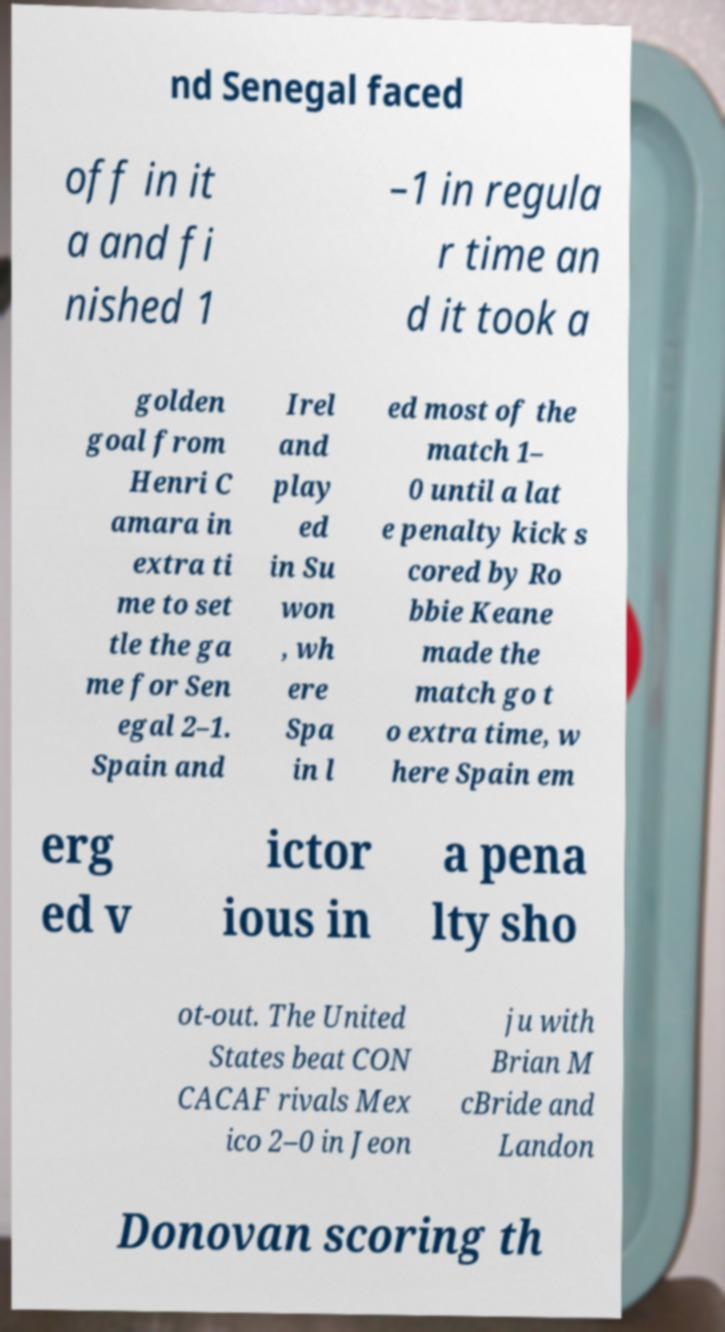Could you assist in decoding the text presented in this image and type it out clearly? nd Senegal faced off in it a and fi nished 1 –1 in regula r time an d it took a golden goal from Henri C amara in extra ti me to set tle the ga me for Sen egal 2–1. Spain and Irel and play ed in Su won , wh ere Spa in l ed most of the match 1– 0 until a lat e penalty kick s cored by Ro bbie Keane made the match go t o extra time, w here Spain em erg ed v ictor ious in a pena lty sho ot-out. The United States beat CON CACAF rivals Mex ico 2–0 in Jeon ju with Brian M cBride and Landon Donovan scoring th 